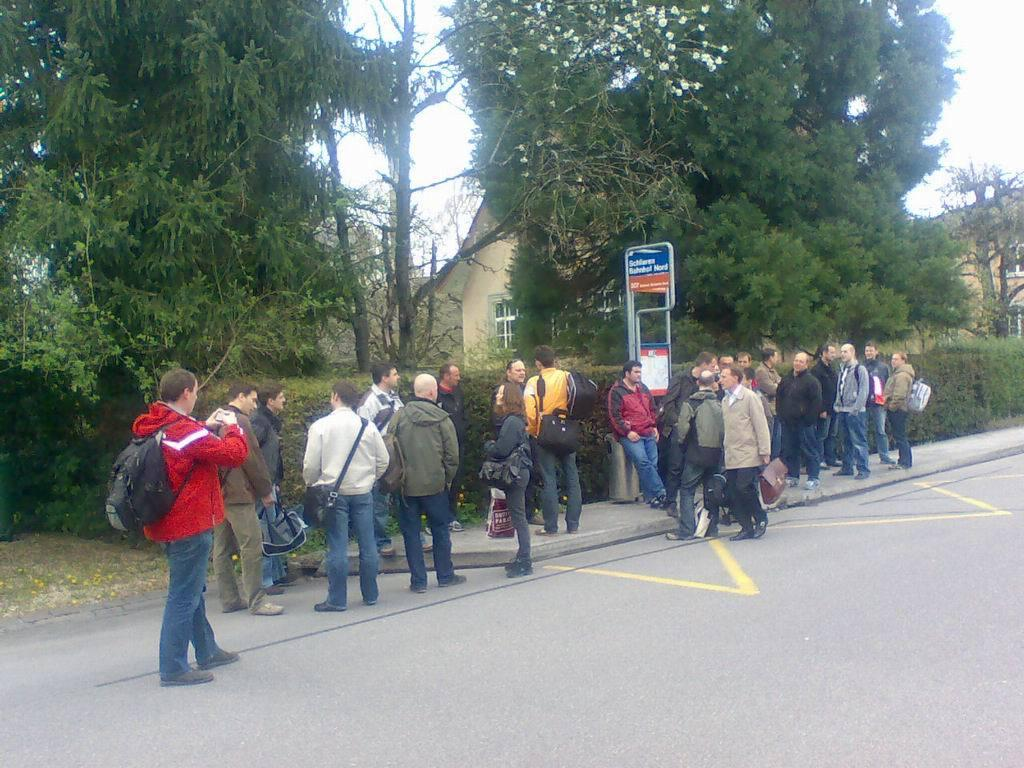How many people are in the image? There is a group of people in the image, but the exact number is not specified. Where are the people located in the image? The people are standing beside the road in the image. What can be seen in the background of the image? There are trees and plants in the background of the image, and houses can be seen behind them. What type of bottle is being used to answer questions in the image? There is no bottle present in the image, and no one is answering questions. 